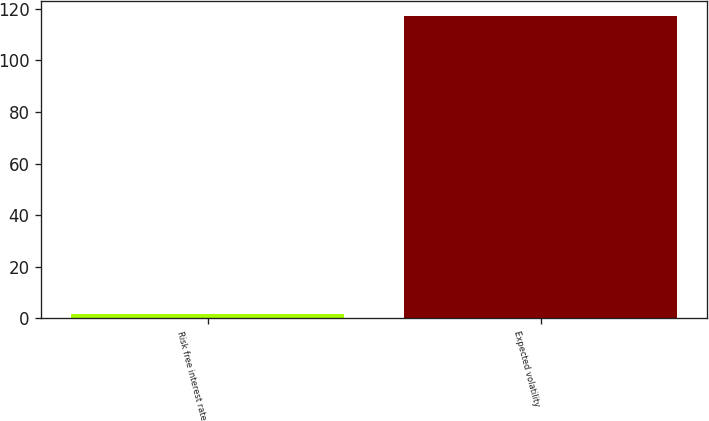Convert chart to OTSL. <chart><loc_0><loc_0><loc_500><loc_500><bar_chart><fcel>Risk free interest rate<fcel>Expected volatility<nl><fcel>1.73<fcel>117<nl></chart> 